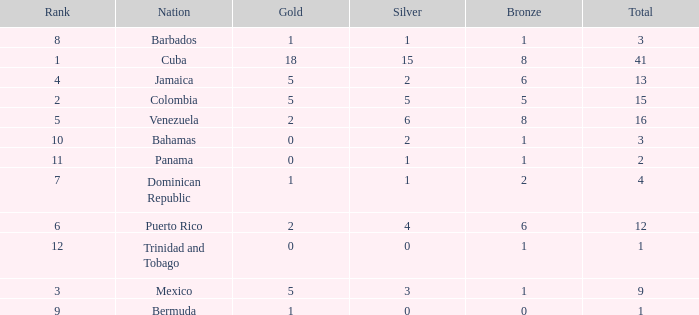Which Total is the lowest one that has a Rank smaller than 2, and a Silver smaller than 15? None. 